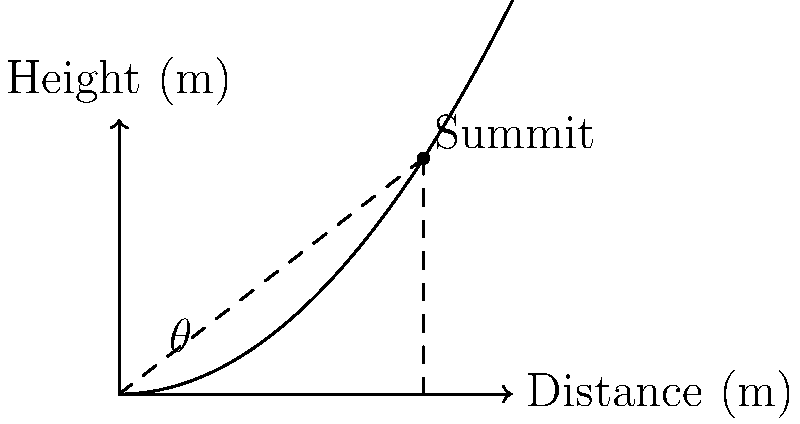During a trekking expedition near Bangalore, you encounter a hill with a height function $h(x) = 0.002x^2$, where $x$ is the horizontal distance from your starting point in meters, and $h(x)$ is the height in meters. If the summit is 300 meters high, what is the angle of elevation (in degrees) needed to reach the top of the hill from your starting point? Let's approach this step-by-step:

1) First, we need to find the horizontal distance to the summit. We know the height function and the summit height:

   $h(x) = 0.002x^2$
   $300 = 0.002x^2$

2) Solve for x:
   $x^2 = 300 / 0.002 = 150,000$
   $x = \sqrt{150,000} \approx 387.3$ meters

3) Now we have a right triangle with:
   - Base (adjacent side) = 387.3 meters
   - Height (opposite side) = 300 meters

4) To find the angle of elevation, we need to use the arctangent function:

   $\theta = \arctan(\frac{\text{opposite}}{\text{adjacent}})$

5) Plugging in our values:

   $\theta = \arctan(\frac{300}{387.3})$

6) Calculate:
   $\theta \approx 37.76$ degrees

Therefore, the angle of elevation needed to reach the summit is approximately 37.76 degrees.
Answer: $37.76^\circ$ 